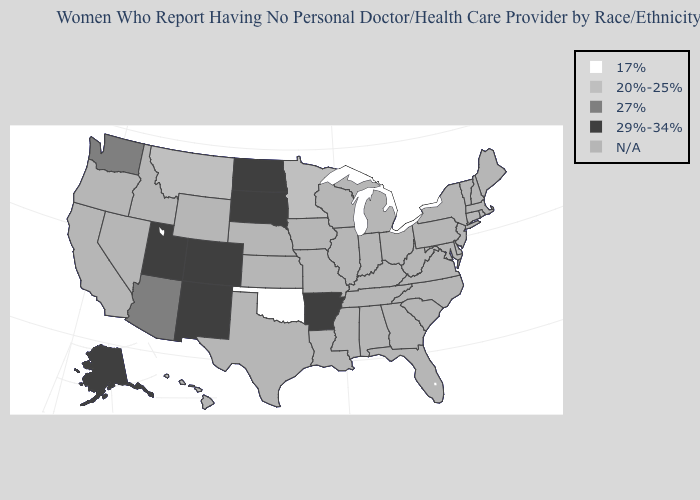Name the states that have a value in the range 20%-25%?
Give a very brief answer. Minnesota, Montana. Name the states that have a value in the range 20%-25%?
Write a very short answer. Minnesota, Montana. Name the states that have a value in the range N/A?
Answer briefly. Alabama, California, Connecticut, Delaware, Florida, Georgia, Hawaii, Idaho, Illinois, Indiana, Iowa, Kansas, Kentucky, Louisiana, Maine, Maryland, Massachusetts, Michigan, Mississippi, Missouri, Nebraska, Nevada, New Hampshire, New Jersey, New York, North Carolina, Ohio, Oregon, Pennsylvania, Rhode Island, South Carolina, Tennessee, Texas, Vermont, Virginia, West Virginia, Wisconsin, Wyoming. Name the states that have a value in the range 20%-25%?
Be succinct. Minnesota, Montana. Among the states that border Colorado , does Arizona have the highest value?
Give a very brief answer. No. Does the first symbol in the legend represent the smallest category?
Write a very short answer. Yes. Name the states that have a value in the range 29%-34%?
Quick response, please. Alaska, Arkansas, Colorado, New Mexico, North Dakota, South Dakota, Utah. Name the states that have a value in the range 20%-25%?
Keep it brief. Minnesota, Montana. Does Minnesota have the lowest value in the MidWest?
Answer briefly. Yes. What is the highest value in states that border Kansas?
Short answer required. 29%-34%. Which states have the highest value in the USA?
Short answer required. Alaska, Arkansas, Colorado, New Mexico, North Dakota, South Dakota, Utah. Which states have the lowest value in the South?
Give a very brief answer. Oklahoma. What is the value of Colorado?
Give a very brief answer. 29%-34%. Name the states that have a value in the range 17%?
Keep it brief. Oklahoma. 